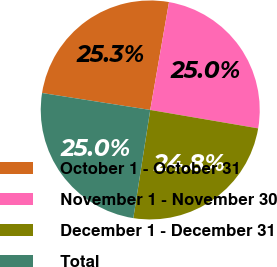Convert chart to OTSL. <chart><loc_0><loc_0><loc_500><loc_500><pie_chart><fcel>October 1 - October 31<fcel>November 1 - November 30<fcel>December 1 - December 31<fcel>Total<nl><fcel>25.27%<fcel>24.95%<fcel>24.78%<fcel>25.0%<nl></chart> 